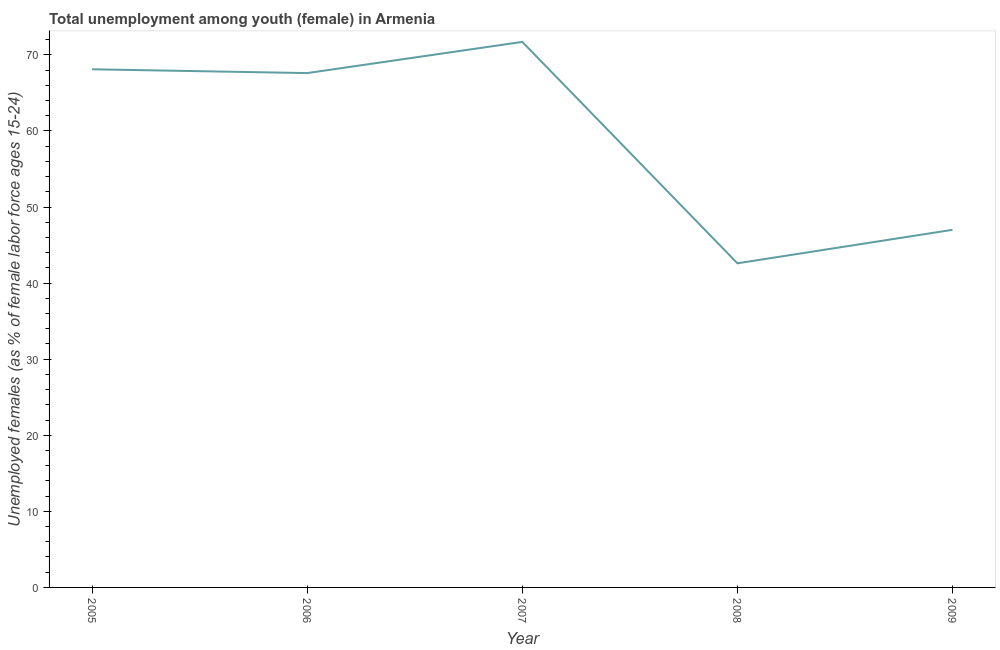What is the unemployed female youth population in 2005?
Offer a very short reply. 68.1. Across all years, what is the maximum unemployed female youth population?
Give a very brief answer. 71.7. Across all years, what is the minimum unemployed female youth population?
Offer a very short reply. 42.6. In which year was the unemployed female youth population minimum?
Your response must be concise. 2008. What is the sum of the unemployed female youth population?
Give a very brief answer. 297. What is the difference between the unemployed female youth population in 2007 and 2008?
Provide a succinct answer. 29.1. What is the average unemployed female youth population per year?
Your response must be concise. 59.4. What is the median unemployed female youth population?
Offer a terse response. 67.6. Do a majority of the years between 2009 and 2005 (inclusive) have unemployed female youth population greater than 14 %?
Offer a very short reply. Yes. What is the ratio of the unemployed female youth population in 2006 to that in 2009?
Provide a short and direct response. 1.44. Is the unemployed female youth population in 2005 less than that in 2008?
Ensure brevity in your answer.  No. What is the difference between the highest and the second highest unemployed female youth population?
Ensure brevity in your answer.  3.6. Is the sum of the unemployed female youth population in 2005 and 2007 greater than the maximum unemployed female youth population across all years?
Provide a short and direct response. Yes. What is the difference between the highest and the lowest unemployed female youth population?
Your answer should be very brief. 29.1. How many lines are there?
Provide a short and direct response. 1. How many years are there in the graph?
Provide a short and direct response. 5. Are the values on the major ticks of Y-axis written in scientific E-notation?
Offer a terse response. No. Does the graph contain grids?
Offer a very short reply. No. What is the title of the graph?
Ensure brevity in your answer.  Total unemployment among youth (female) in Armenia. What is the label or title of the Y-axis?
Your answer should be compact. Unemployed females (as % of female labor force ages 15-24). What is the Unemployed females (as % of female labor force ages 15-24) in 2005?
Make the answer very short. 68.1. What is the Unemployed females (as % of female labor force ages 15-24) in 2006?
Offer a very short reply. 67.6. What is the Unemployed females (as % of female labor force ages 15-24) of 2007?
Offer a very short reply. 71.7. What is the Unemployed females (as % of female labor force ages 15-24) of 2008?
Your response must be concise. 42.6. What is the Unemployed females (as % of female labor force ages 15-24) of 2009?
Provide a succinct answer. 47. What is the difference between the Unemployed females (as % of female labor force ages 15-24) in 2005 and 2006?
Offer a terse response. 0.5. What is the difference between the Unemployed females (as % of female labor force ages 15-24) in 2005 and 2008?
Give a very brief answer. 25.5. What is the difference between the Unemployed females (as % of female labor force ages 15-24) in 2005 and 2009?
Give a very brief answer. 21.1. What is the difference between the Unemployed females (as % of female labor force ages 15-24) in 2006 and 2009?
Provide a short and direct response. 20.6. What is the difference between the Unemployed females (as % of female labor force ages 15-24) in 2007 and 2008?
Offer a terse response. 29.1. What is the difference between the Unemployed females (as % of female labor force ages 15-24) in 2007 and 2009?
Keep it short and to the point. 24.7. What is the difference between the Unemployed females (as % of female labor force ages 15-24) in 2008 and 2009?
Keep it short and to the point. -4.4. What is the ratio of the Unemployed females (as % of female labor force ages 15-24) in 2005 to that in 2006?
Ensure brevity in your answer.  1.01. What is the ratio of the Unemployed females (as % of female labor force ages 15-24) in 2005 to that in 2008?
Keep it short and to the point. 1.6. What is the ratio of the Unemployed females (as % of female labor force ages 15-24) in 2005 to that in 2009?
Offer a very short reply. 1.45. What is the ratio of the Unemployed females (as % of female labor force ages 15-24) in 2006 to that in 2007?
Offer a terse response. 0.94. What is the ratio of the Unemployed females (as % of female labor force ages 15-24) in 2006 to that in 2008?
Offer a very short reply. 1.59. What is the ratio of the Unemployed females (as % of female labor force ages 15-24) in 2006 to that in 2009?
Give a very brief answer. 1.44. What is the ratio of the Unemployed females (as % of female labor force ages 15-24) in 2007 to that in 2008?
Your answer should be compact. 1.68. What is the ratio of the Unemployed females (as % of female labor force ages 15-24) in 2007 to that in 2009?
Your answer should be compact. 1.53. What is the ratio of the Unemployed females (as % of female labor force ages 15-24) in 2008 to that in 2009?
Ensure brevity in your answer.  0.91. 